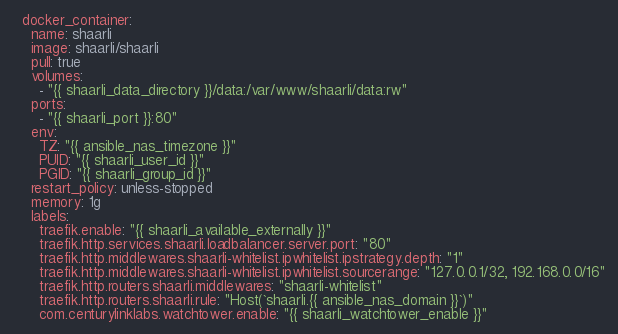Convert code to text. <code><loc_0><loc_0><loc_500><loc_500><_YAML_>  docker_container:
    name: shaarli
    image: shaarli/shaarli
    pull: true
    volumes:
      - "{{ shaarli_data_directory }}/data:/var/www/shaarli/data:rw"
    ports:
      - "{{ shaarli_port }}:80"
    env:
      TZ: "{{ ansible_nas_timezone }}"
      PUID: "{{ shaarli_user_id }}"
      PGID: "{{ shaarli_group_id }}"
    restart_policy: unless-stopped
    memory: 1g
    labels:
      traefik.enable: "{{ shaarli_available_externally }}"
      traefik.http.services.shaarli.loadbalancer.server.port: "80"
      traefik.http.middlewares.shaarli-whitelist.ipwhitelist.ipstrategy.depth: "1"
      traefik.http.middlewares.shaarli-whitelist.ipwhitelist.sourcerange: "127.0.0.1/32, 192.168.0.0/16"
      traefik.http.routers.shaarli.middlewares: "shaarli-whitelist"
      traefik.http.routers.shaarli.rule: "Host(`shaarli.{{ ansible_nas_domain }}`)"
      com.centurylinklabs.watchtower.enable: "{{ shaarli_watchtower_enable }}"
</code> 